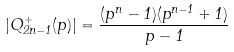<formula> <loc_0><loc_0><loc_500><loc_500>| Q _ { 2 n - 1 } ^ { + } ( p ) | = \frac { ( p ^ { n } - 1 ) ( p ^ { n - 1 } + 1 ) } { p - 1 }</formula> 